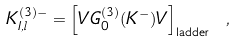<formula> <loc_0><loc_0><loc_500><loc_500>K _ { I , l } ^ { ( 3 ) - } = \left [ V G _ { 0 } ^ { ( 3 ) } ( K ^ { - } ) V \right ] _ { \text {ladder} } \ ,</formula> 